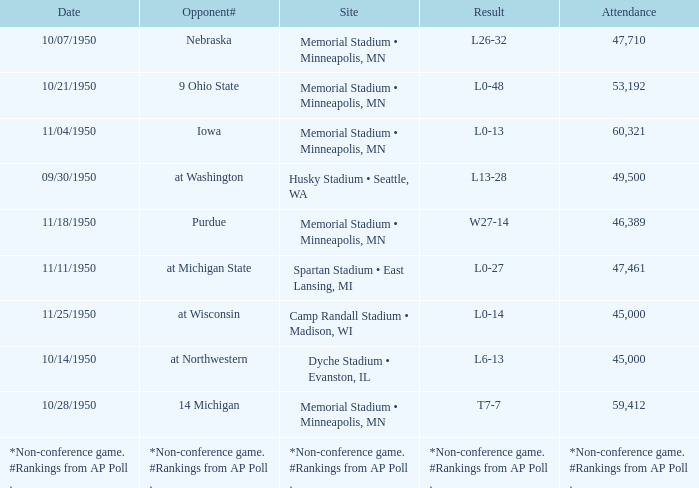What is the Attendance when the Result is l0-13? 60321.0. 